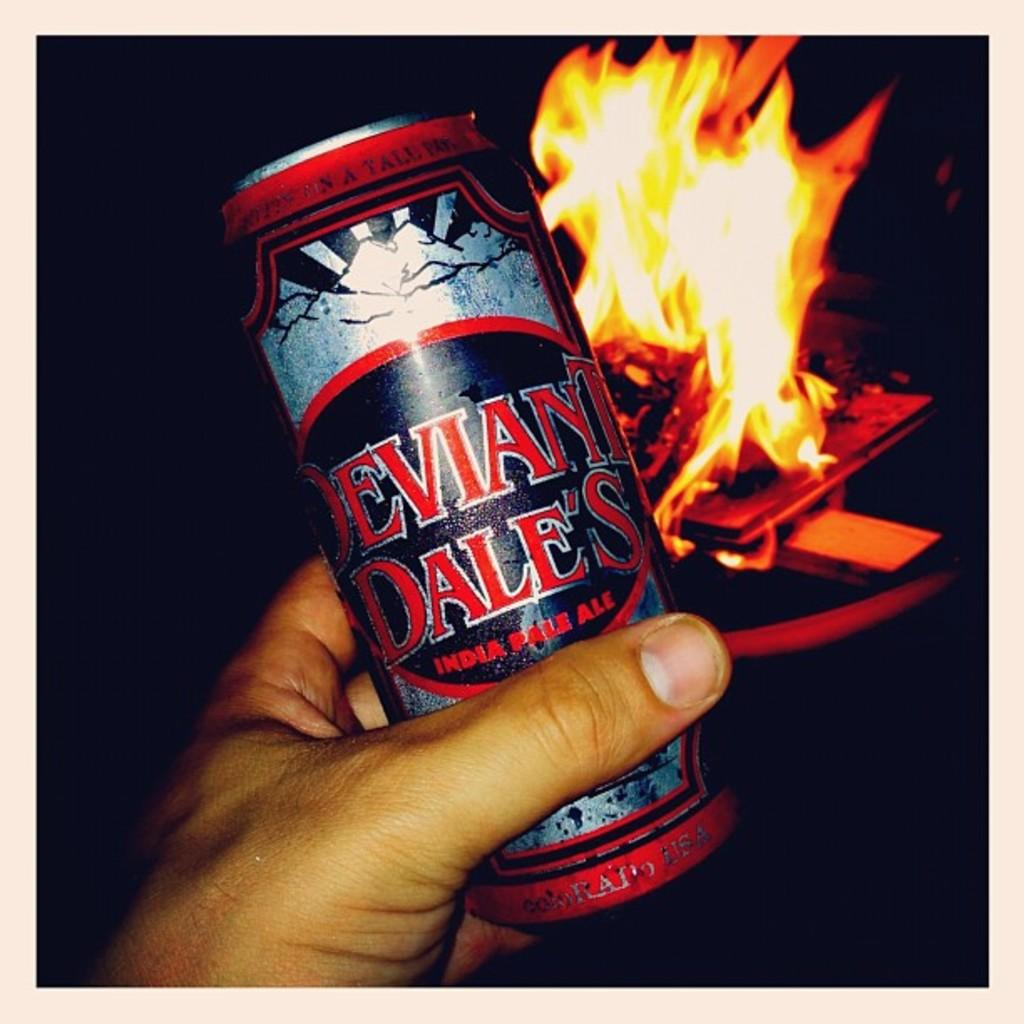<image>
Relay a brief, clear account of the picture shown. A hand is holding a can of India pale ale in front of a fire. 